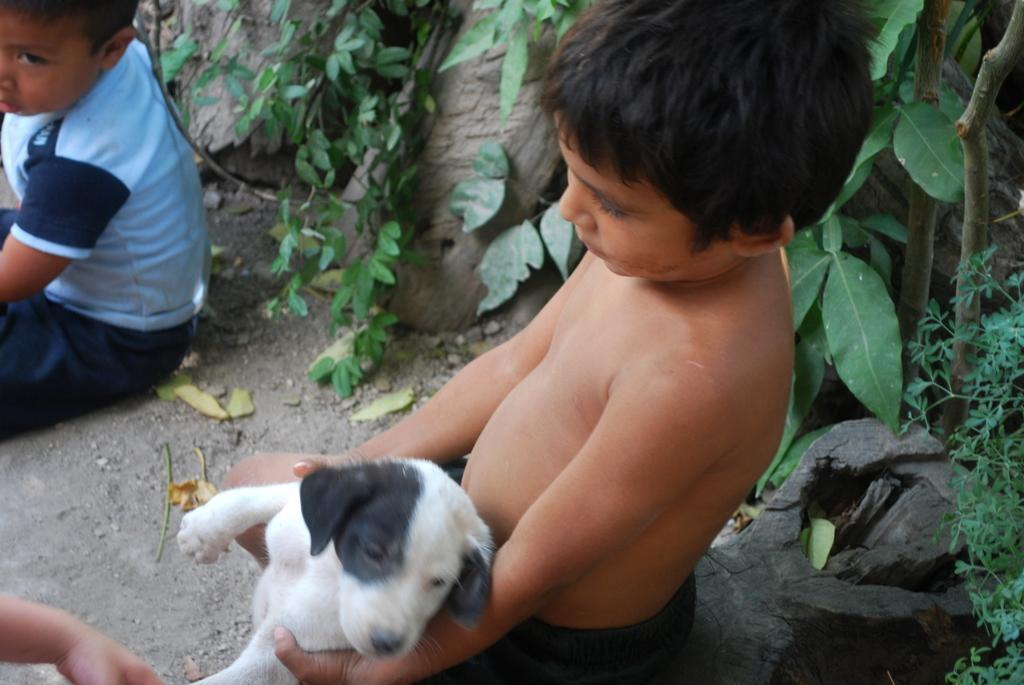Who is the main subject in the image? There is a boy in the image. What is the boy doing in the image? The boy is holding a dog with his hands. Are there any other objects or living beings in the image? Yes, there is a plant in the image. What type of mountain can be seen in the background of the image? There is no mountain visible in the image; it only features a boy holding a dog and a plant. 